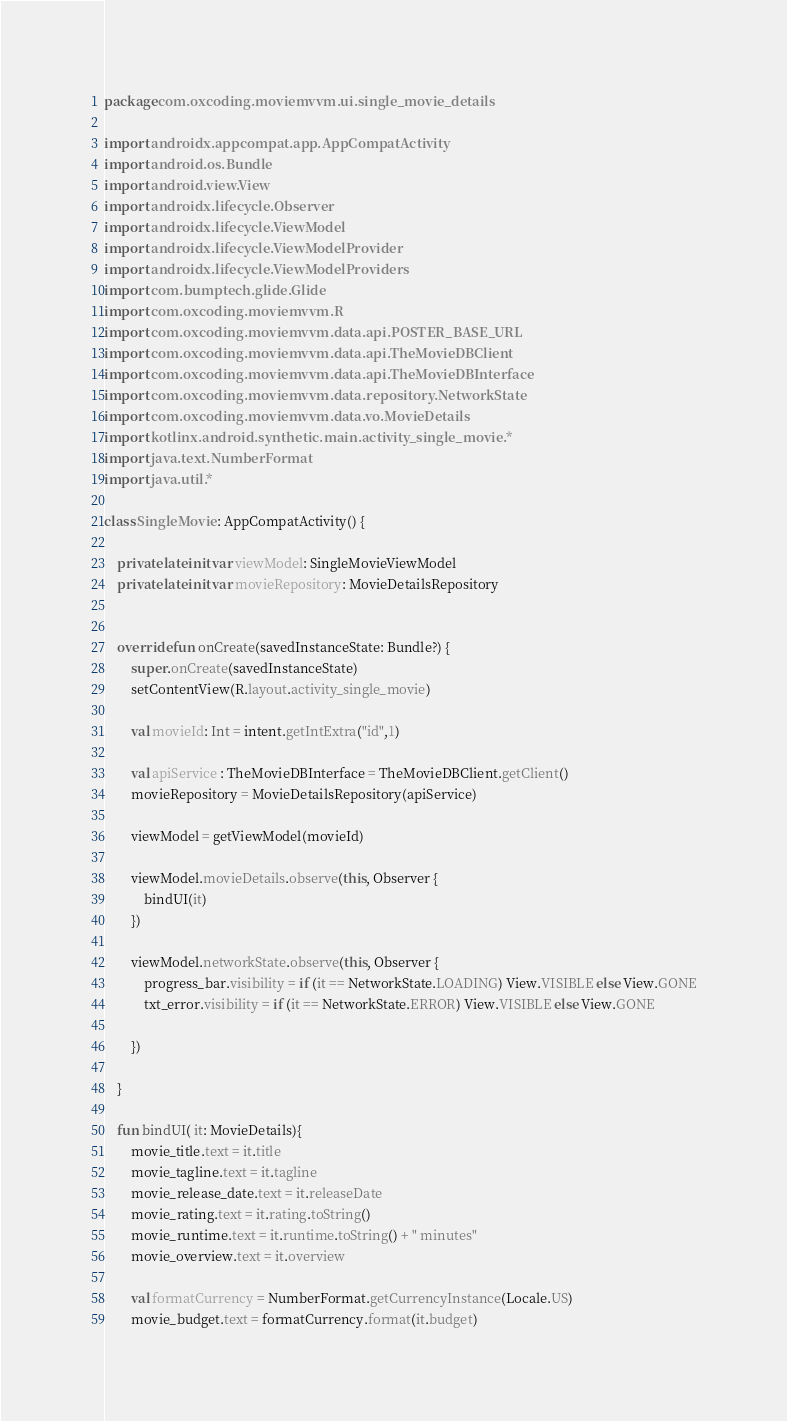Convert code to text. <code><loc_0><loc_0><loc_500><loc_500><_Kotlin_>package com.oxcoding.moviemvvm.ui.single_movie_details

import androidx.appcompat.app.AppCompatActivity
import android.os.Bundle
import android.view.View
import androidx.lifecycle.Observer
import androidx.lifecycle.ViewModel
import androidx.lifecycle.ViewModelProvider
import androidx.lifecycle.ViewModelProviders
import com.bumptech.glide.Glide
import com.oxcoding.moviemvvm.R
import com.oxcoding.moviemvvm.data.api.POSTER_BASE_URL
import com.oxcoding.moviemvvm.data.api.TheMovieDBClient
import com.oxcoding.moviemvvm.data.api.TheMovieDBInterface
import com.oxcoding.moviemvvm.data.repository.NetworkState
import com.oxcoding.moviemvvm.data.vo.MovieDetails
import kotlinx.android.synthetic.main.activity_single_movie.*
import java.text.NumberFormat
import java.util.*

class SingleMovie : AppCompatActivity() {

    private lateinit var viewModel: SingleMovieViewModel
    private lateinit var movieRepository: MovieDetailsRepository


    override fun onCreate(savedInstanceState: Bundle?) {
        super.onCreate(savedInstanceState)
        setContentView(R.layout.activity_single_movie)

        val movieId: Int = intent.getIntExtra("id",1)

        val apiService : TheMovieDBInterface = TheMovieDBClient.getClient()
        movieRepository = MovieDetailsRepository(apiService)

        viewModel = getViewModel(movieId)

        viewModel.movieDetails.observe(this, Observer {
            bindUI(it)
        })

        viewModel.networkState.observe(this, Observer {
            progress_bar.visibility = if (it == NetworkState.LOADING) View.VISIBLE else View.GONE
            txt_error.visibility = if (it == NetworkState.ERROR) View.VISIBLE else View.GONE

        })

    }

    fun bindUI( it: MovieDetails){
        movie_title.text = it.title
        movie_tagline.text = it.tagline
        movie_release_date.text = it.releaseDate
        movie_rating.text = it.rating.toString()
        movie_runtime.text = it.runtime.toString() + " minutes"
        movie_overview.text = it.overview

        val formatCurrency = NumberFormat.getCurrencyInstance(Locale.US)
        movie_budget.text = formatCurrency.format(it.budget)</code> 